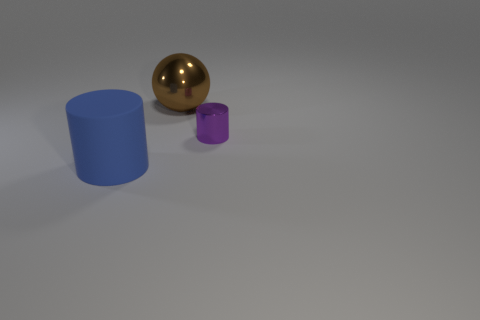Add 3 small green matte things. How many objects exist? 6 Subtract all cylinders. How many objects are left? 1 Add 1 cyan rubber balls. How many cyan rubber balls exist? 1 Subtract 0 brown cylinders. How many objects are left? 3 Subtract all purple cylinders. Subtract all big blue things. How many objects are left? 1 Add 2 metal balls. How many metal balls are left? 3 